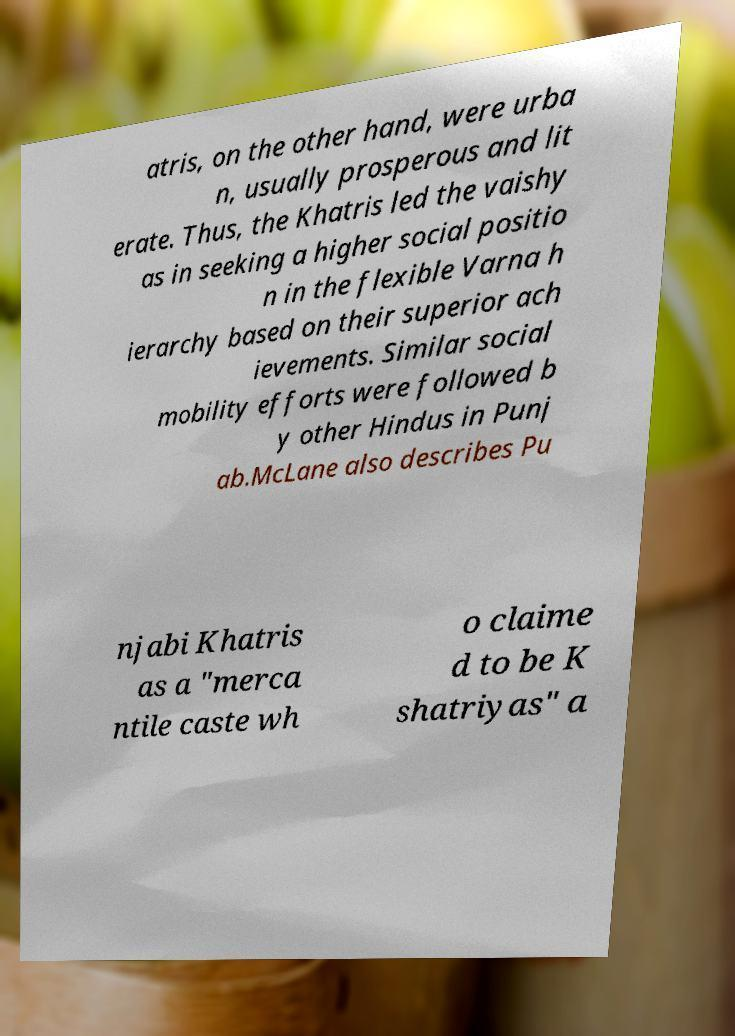Please read and relay the text visible in this image. What does it say? atris, on the other hand, were urba n, usually prosperous and lit erate. Thus, the Khatris led the vaishy as in seeking a higher social positio n in the flexible Varna h ierarchy based on their superior ach ievements. Similar social mobility efforts were followed b y other Hindus in Punj ab.McLane also describes Pu njabi Khatris as a "merca ntile caste wh o claime d to be K shatriyas" a 